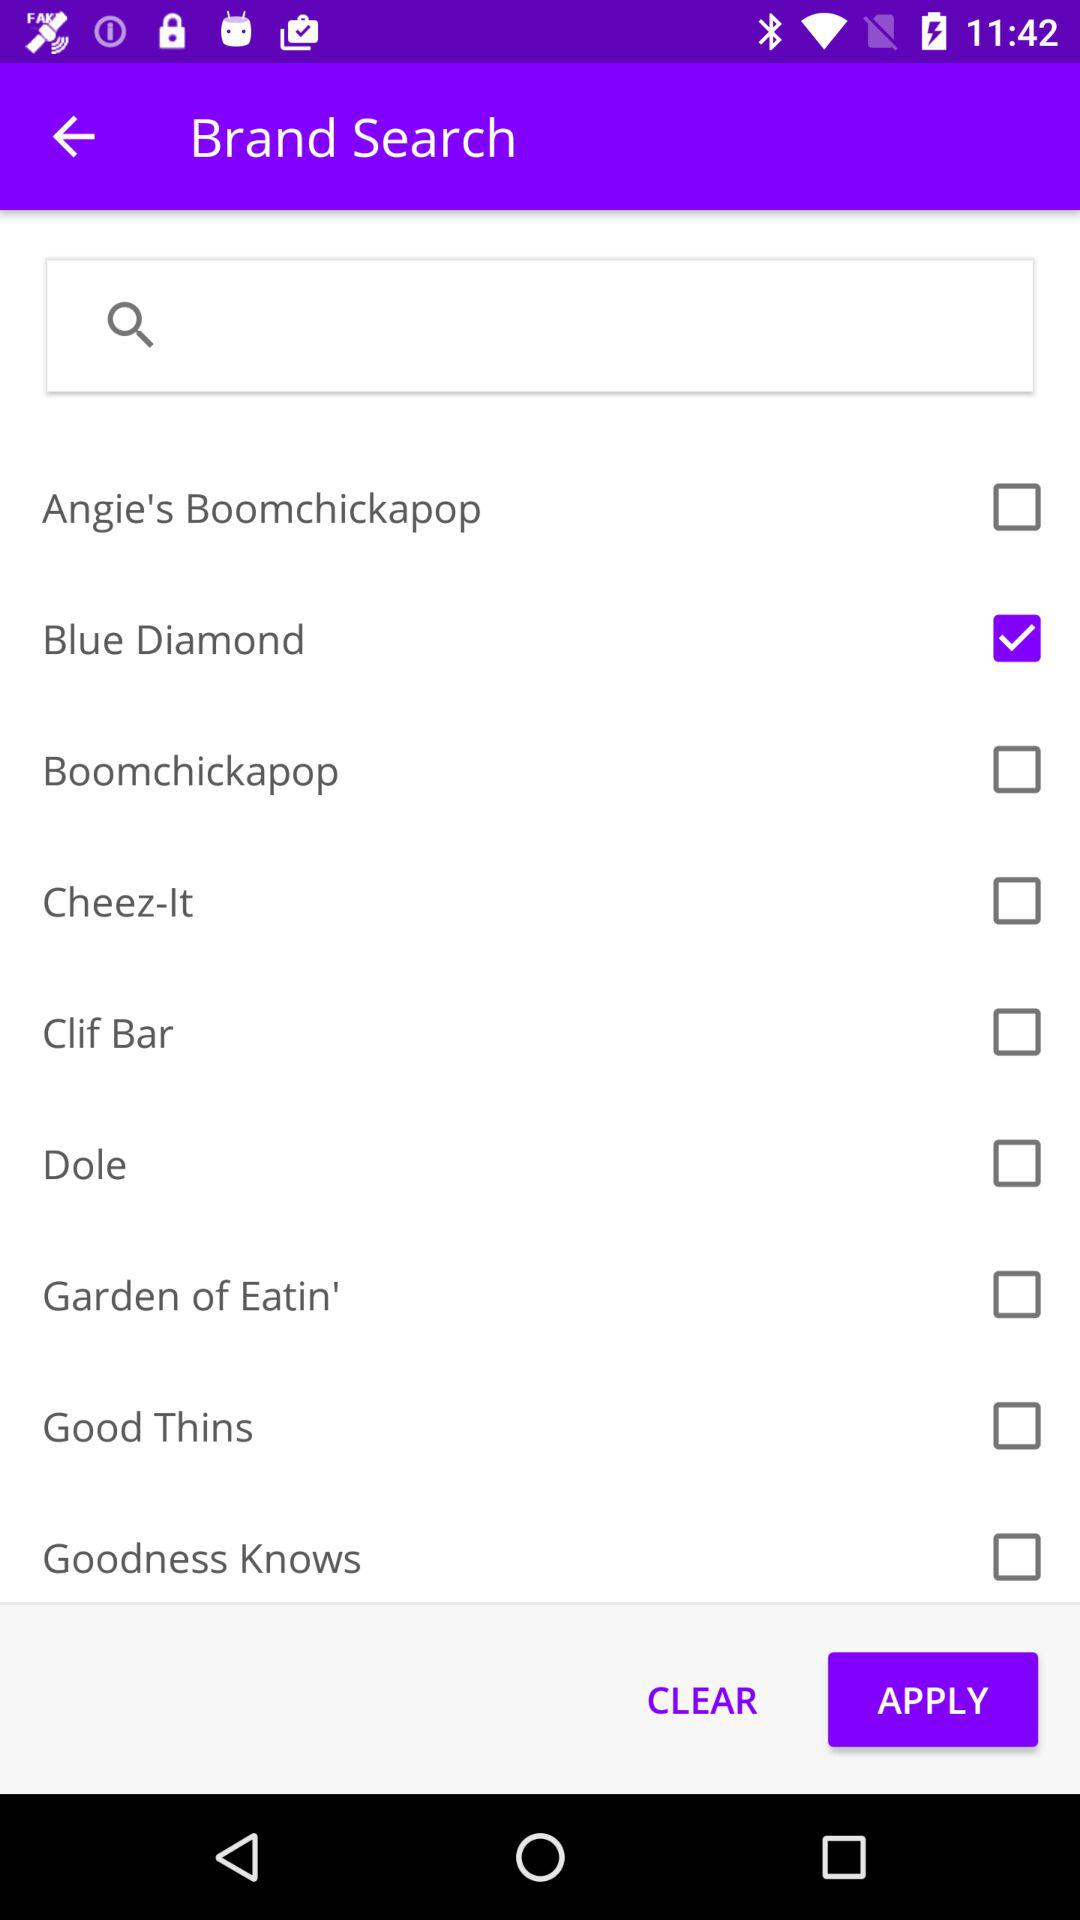What are the names of the brands shown in the list? The names of the brands are "Angie's Boomchickapop", "Blue Diamond", "Boomchickapop", "Cheez-It", "Clif Bar", "Dole", "Garden of Eatin'", "Good Thins" and "Goodness Knows". 